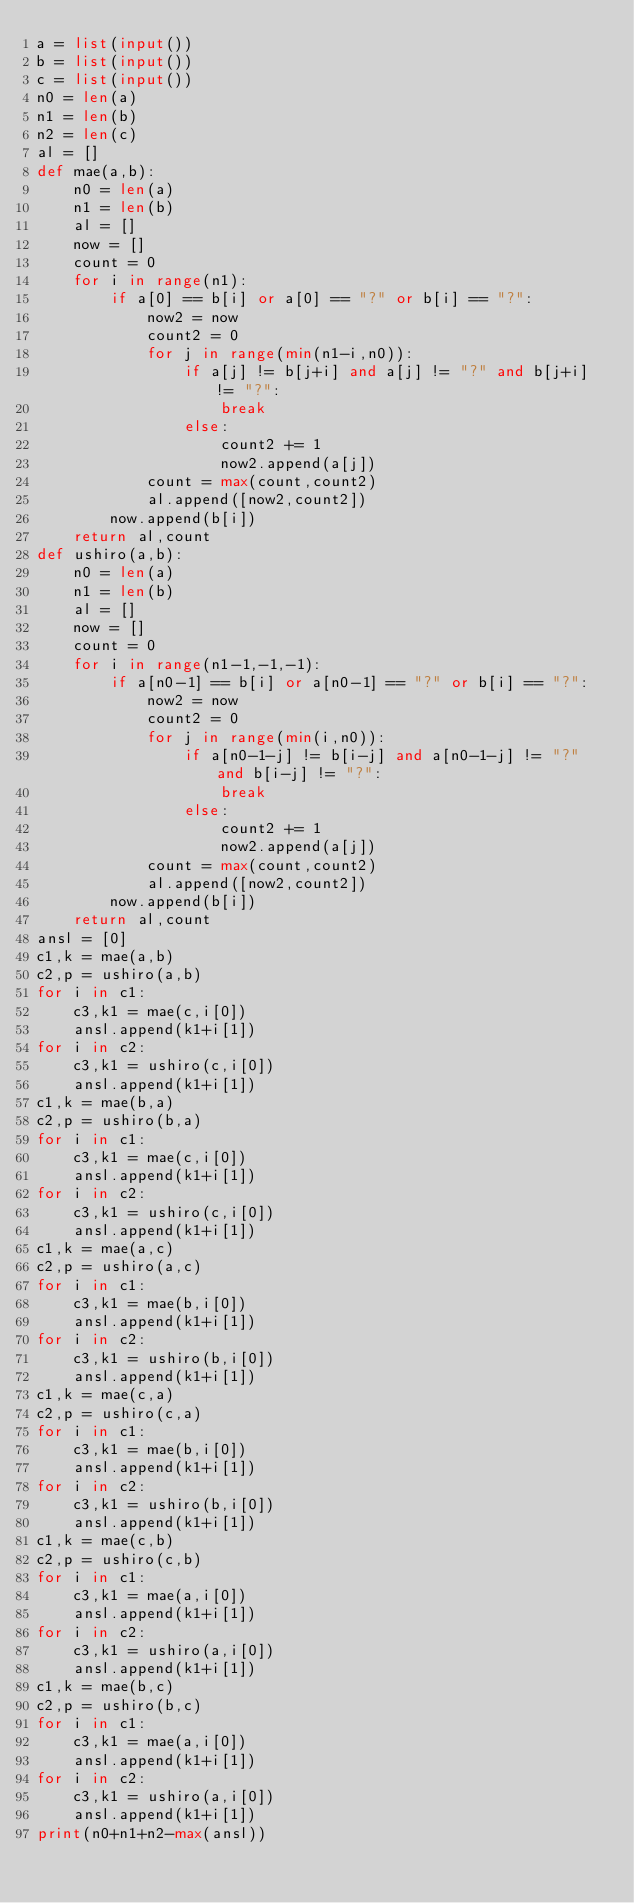Convert code to text. <code><loc_0><loc_0><loc_500><loc_500><_Python_>a = list(input())
b = list(input())
c = list(input())
n0 = len(a)
n1 = len(b)
n2 = len(c)
al = []
def mae(a,b):
    n0 = len(a)
    n1 = len(b)
    al = []
    now = []
    count = 0
    for i in range(n1):
        if a[0] == b[i] or a[0] == "?" or b[i] == "?":
            now2 = now
            count2 = 0
            for j in range(min(n1-i,n0)):
                if a[j] != b[j+i] and a[j] != "?" and b[j+i] != "?":
                    break
                else:
                    count2 += 1
                    now2.append(a[j])
            count = max(count,count2)
            al.append([now2,count2])
        now.append(b[i])
    return al,count
def ushiro(a,b):
    n0 = len(a)
    n1 = len(b)
    al = []
    now = []
    count = 0
    for i in range(n1-1,-1,-1):
        if a[n0-1] == b[i] or a[n0-1] == "?" or b[i] == "?":
            now2 = now
            count2 = 0
            for j in range(min(i,n0)):
                if a[n0-1-j] != b[i-j] and a[n0-1-j] != "?" and b[i-j] != "?":
                    break
                else:
                    count2 += 1
                    now2.append(a[j])
            count = max(count,count2)
            al.append([now2,count2])
        now.append(b[i])
    return al,count
ansl = [0]
c1,k = mae(a,b)
c2,p = ushiro(a,b)
for i in c1:
    c3,k1 = mae(c,i[0])
    ansl.append(k1+i[1])
for i in c2:
    c3,k1 = ushiro(c,i[0])
    ansl.append(k1+i[1])
c1,k = mae(b,a)
c2,p = ushiro(b,a)
for i in c1:
    c3,k1 = mae(c,i[0])
    ansl.append(k1+i[1])
for i in c2:
    c3,k1 = ushiro(c,i[0])
    ansl.append(k1+i[1])
c1,k = mae(a,c)
c2,p = ushiro(a,c)
for i in c1:
    c3,k1 = mae(b,i[0])
    ansl.append(k1+i[1])
for i in c2:
    c3,k1 = ushiro(b,i[0])
    ansl.append(k1+i[1])
c1,k = mae(c,a)
c2,p = ushiro(c,a)
for i in c1:
    c3,k1 = mae(b,i[0])
    ansl.append(k1+i[1])
for i in c2:
    c3,k1 = ushiro(b,i[0])
    ansl.append(k1+i[1])
c1,k = mae(c,b)
c2,p = ushiro(c,b)
for i in c1:
    c3,k1 = mae(a,i[0])
    ansl.append(k1+i[1])
for i in c2:
    c3,k1 = ushiro(a,i[0])
    ansl.append(k1+i[1])
c1,k = mae(b,c)
c2,p = ushiro(b,c)
for i in c1:
    c3,k1 = mae(a,i[0])
    ansl.append(k1+i[1])
for i in c2:
    c3,k1 = ushiro(a,i[0])
    ansl.append(k1+i[1])
print(n0+n1+n2-max(ansl))</code> 